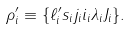<formula> <loc_0><loc_0><loc_500><loc_500>\rho _ { i } ^ { \prime } \equiv \{ \ell _ { i } ^ { \prime } s _ { i } j _ { i } i _ { i } \lambda _ { i } J _ { i } \} .</formula> 